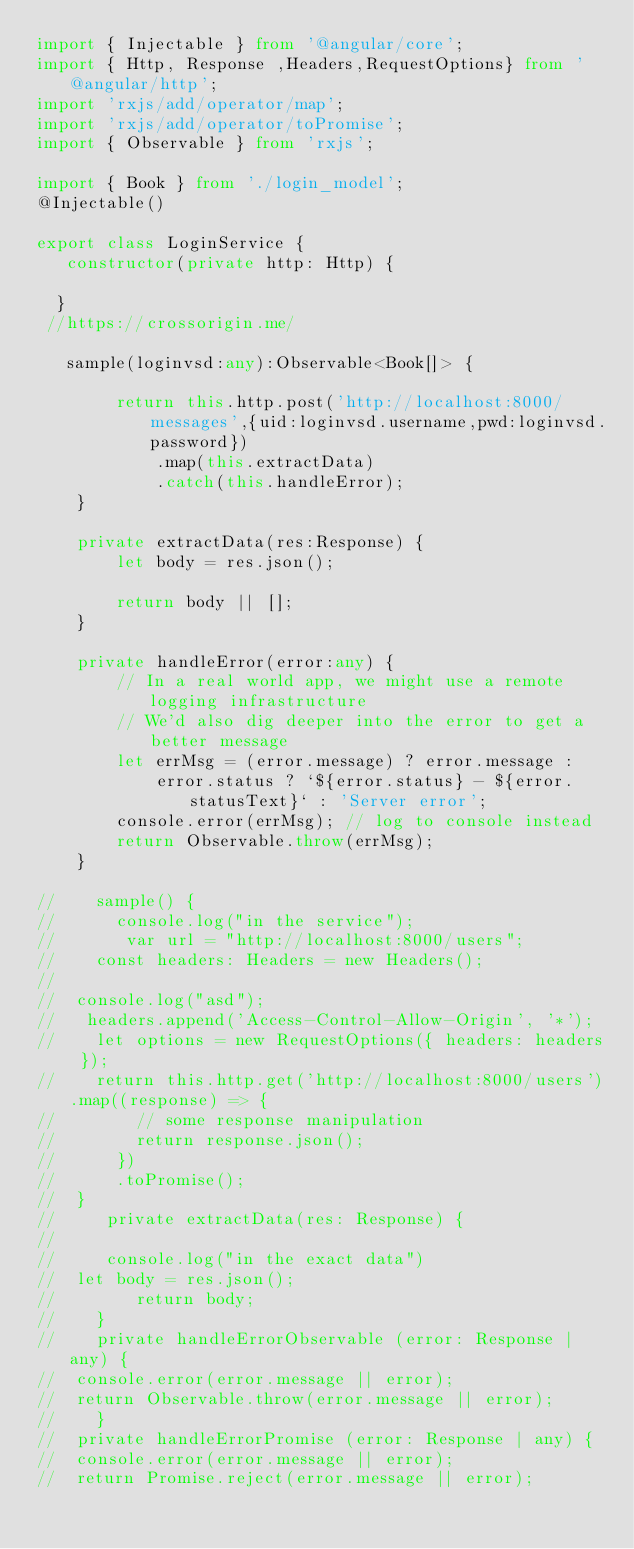<code> <loc_0><loc_0><loc_500><loc_500><_TypeScript_>import { Injectable } from '@angular/core';
import { Http, Response ,Headers,RequestOptions} from '@angular/http';
import 'rxjs/add/operator/map';
import 'rxjs/add/operator/toPromise';
import { Observable } from 'rxjs';

import { Book } from './login_model';
@Injectable()

export class LoginService {
   constructor(private http: Http) {

  }
 //https://crossorigin.me/
  
   sample(loginvsd:any):Observable<Book[]> {
    
        return this.http.post('http://localhost:8000/messages',{uid:loginvsd.username,pwd:loginvsd.password})
            .map(this.extractData)
            .catch(this.handleError);
    }

    private extractData(res:Response) {
        let body = res.json();
      
        return body || [];
    }

    private handleError(error:any) {
        // In a real world app, we might use a remote logging infrastructure
        // We'd also dig deeper into the error to get a better message
        let errMsg = (error.message) ? error.message :
            error.status ? `${error.status} - ${error.statusText}` : 'Server error';
        console.error(errMsg); // log to console instead
        return Observable.throw(errMsg);
    }
  
//    sample() {
//      console.log("in the service");
//       var url = "http://localhost:8000/users";
//    const headers: Headers = new Headers();
//
//  console.log("asd");
//   headers.append('Access-Control-Allow-Origin', '*');
//    let options = new RequestOptions({ headers: headers });
//    return this.http.get('http://localhost:8000/users').map((response) => {
//        // some response manipulation
//        return response.json();
//      })
//      .toPromise();
//  }
//     private extractData(res: Response) {
//       
//     console.log("in the exact data")
//  let body = res.json();
//        return body;
//    }
//    private handleErrorObservable (error: Response | any) {
//  console.error(error.message || error);
//  return Observable.throw(error.message || error);
//    }
//  private handleErrorPromise (error: Response | any) {
//  console.error(error.message || error);
//  return Promise.reject(error.message || error);</code> 